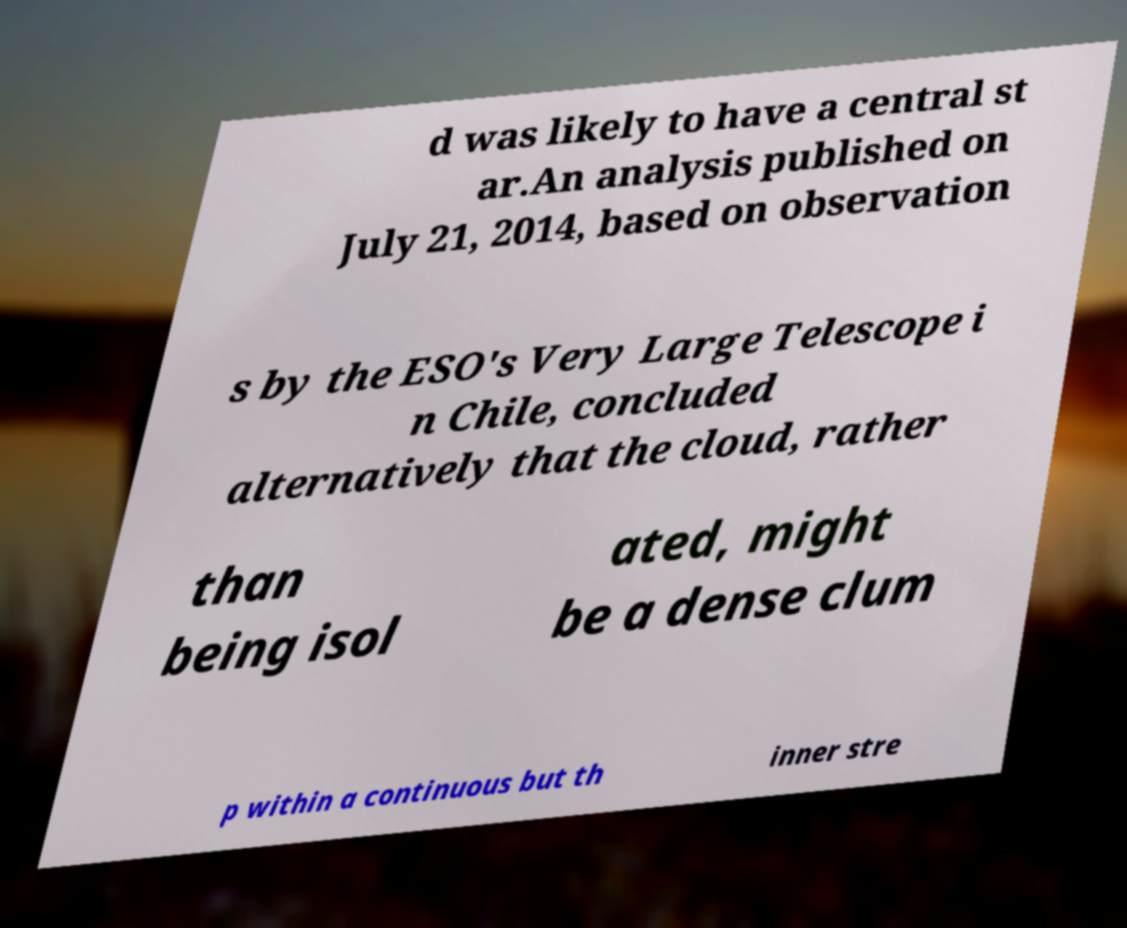I need the written content from this picture converted into text. Can you do that? d was likely to have a central st ar.An analysis published on July 21, 2014, based on observation s by the ESO's Very Large Telescope i n Chile, concluded alternatively that the cloud, rather than being isol ated, might be a dense clum p within a continuous but th inner stre 